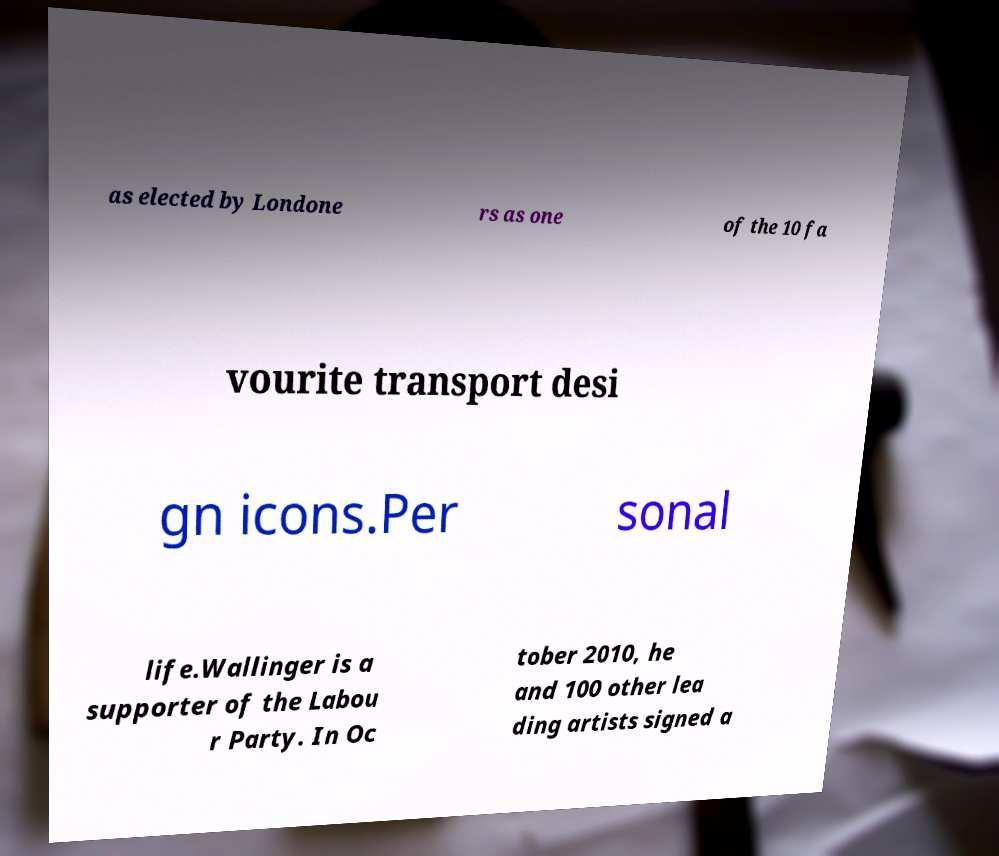For documentation purposes, I need the text within this image transcribed. Could you provide that? as elected by Londone rs as one of the 10 fa vourite transport desi gn icons.Per sonal life.Wallinger is a supporter of the Labou r Party. In Oc tober 2010, he and 100 other lea ding artists signed a 